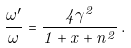Convert formula to latex. <formula><loc_0><loc_0><loc_500><loc_500>\frac { \omega ^ { \prime } } { \omega } = \frac { 4 \gamma ^ { 2 } } { 1 + x + n ^ { 2 } } \, .</formula> 